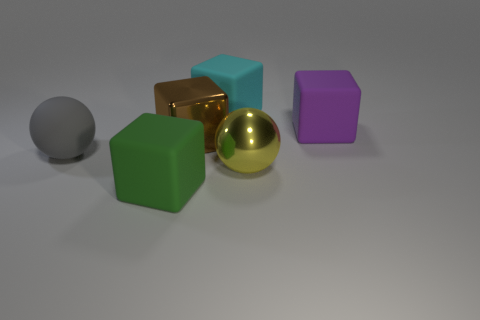Add 2 big cyan things. How many objects exist? 8 Subtract all spheres. How many objects are left? 4 Add 1 purple metallic spheres. How many purple metallic spheres exist? 1 Subtract 0 blue blocks. How many objects are left? 6 Subtract all large yellow shiny things. Subtract all brown objects. How many objects are left? 4 Add 1 metallic things. How many metallic things are left? 3 